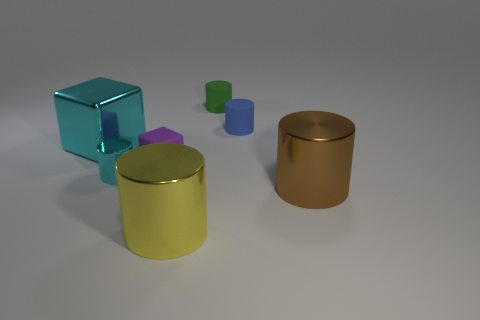Subtract all green cylinders. How many cylinders are left? 4 Subtract all red cylinders. Subtract all red spheres. How many cylinders are left? 5 Add 1 small yellow rubber cylinders. How many objects exist? 8 Subtract all cubes. How many objects are left? 5 Subtract all purple blocks. Subtract all tiny blue blocks. How many objects are left? 6 Add 6 tiny purple matte cubes. How many tiny purple matte cubes are left? 7 Add 6 small purple things. How many small purple things exist? 7 Subtract 0 brown balls. How many objects are left? 7 